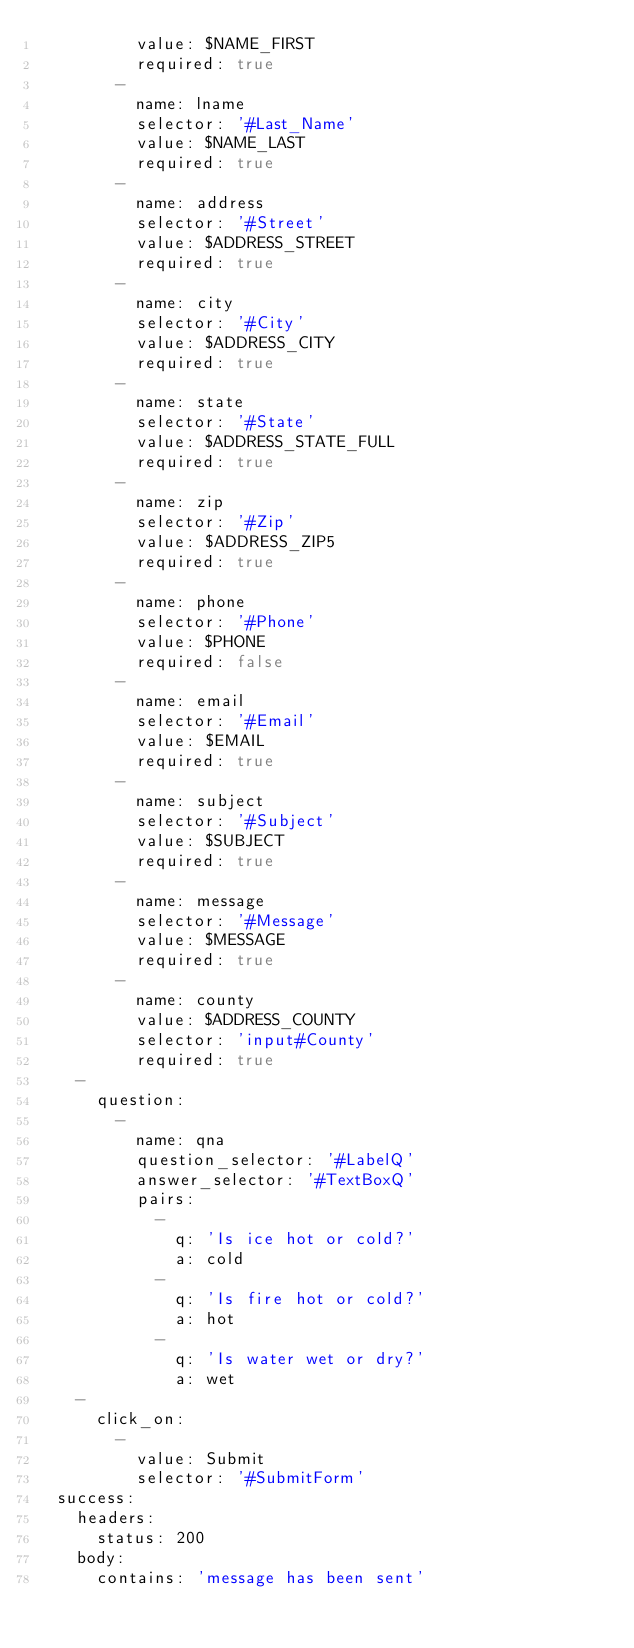<code> <loc_0><loc_0><loc_500><loc_500><_YAML_>          value: $NAME_FIRST
          required: true
        -
          name: lname
          selector: '#Last_Name'
          value: $NAME_LAST
          required: true
        -
          name: address
          selector: '#Street'
          value: $ADDRESS_STREET
          required: true
        -
          name: city
          selector: '#City'
          value: $ADDRESS_CITY
          required: true
        -
          name: state
          selector: '#State'
          value: $ADDRESS_STATE_FULL
          required: true
        -
          name: zip
          selector: '#Zip'
          value: $ADDRESS_ZIP5
          required: true
        -
          name: phone
          selector: '#Phone'
          value: $PHONE
          required: false
        -
          name: email
          selector: '#Email'
          value: $EMAIL
          required: true
        -
          name: subject
          selector: '#Subject'
          value: $SUBJECT
          required: true
        -
          name: message
          selector: '#Message'
          value: $MESSAGE
          required: true
        -
          name: county
          value: $ADDRESS_COUNTY
          selector: 'input#County'
          required: true
    -
      question:
        -
          name: qna
          question_selector: '#LabelQ'
          answer_selector: '#TextBoxQ'
          pairs:
            -
              q: 'Is ice hot or cold?'
              a: cold
            -
              q: 'Is fire hot or cold?'
              a: hot
            -
              q: 'Is water wet or dry?'
              a: wet
    -
      click_on:
        -
          value: Submit
          selector: '#SubmitForm'
  success:
    headers:
      status: 200
    body:
      contains: 'message has been sent'
</code> 